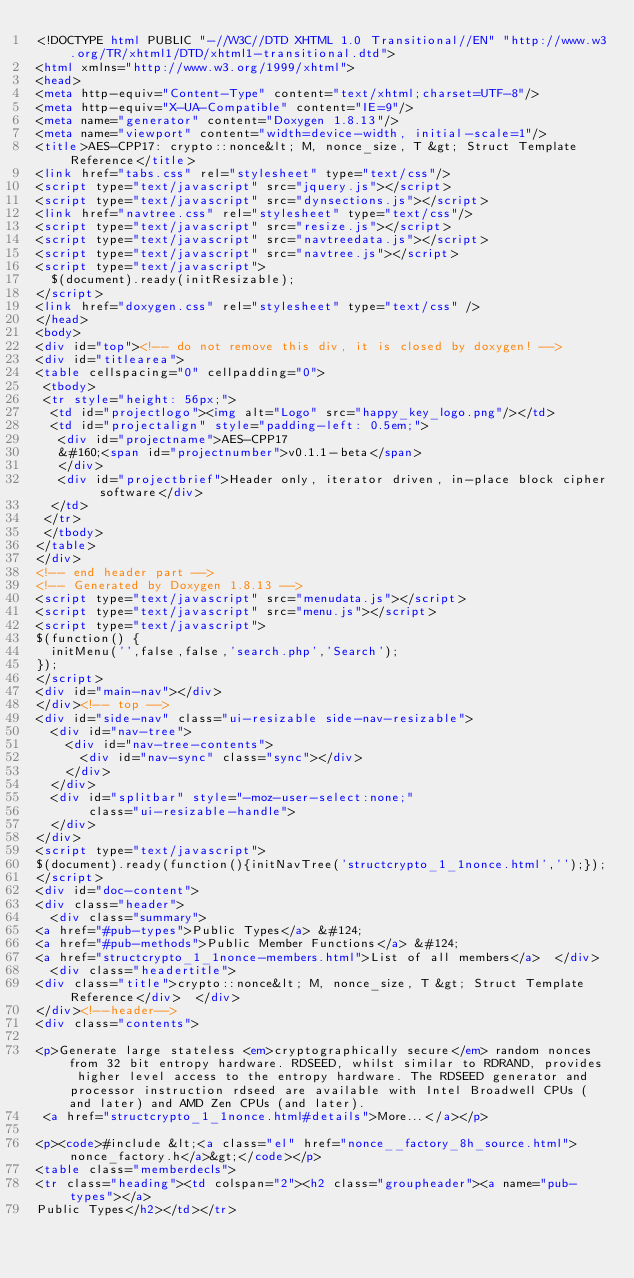Convert code to text. <code><loc_0><loc_0><loc_500><loc_500><_HTML_><!DOCTYPE html PUBLIC "-//W3C//DTD XHTML 1.0 Transitional//EN" "http://www.w3.org/TR/xhtml1/DTD/xhtml1-transitional.dtd">
<html xmlns="http://www.w3.org/1999/xhtml">
<head>
<meta http-equiv="Content-Type" content="text/xhtml;charset=UTF-8"/>
<meta http-equiv="X-UA-Compatible" content="IE=9"/>
<meta name="generator" content="Doxygen 1.8.13"/>
<meta name="viewport" content="width=device-width, initial-scale=1"/>
<title>AES-CPP17: crypto::nonce&lt; M, nonce_size, T &gt; Struct Template Reference</title>
<link href="tabs.css" rel="stylesheet" type="text/css"/>
<script type="text/javascript" src="jquery.js"></script>
<script type="text/javascript" src="dynsections.js"></script>
<link href="navtree.css" rel="stylesheet" type="text/css"/>
<script type="text/javascript" src="resize.js"></script>
<script type="text/javascript" src="navtreedata.js"></script>
<script type="text/javascript" src="navtree.js"></script>
<script type="text/javascript">
  $(document).ready(initResizable);
</script>
<link href="doxygen.css" rel="stylesheet" type="text/css" />
</head>
<body>
<div id="top"><!-- do not remove this div, it is closed by doxygen! -->
<div id="titlearea">
<table cellspacing="0" cellpadding="0">
 <tbody>
 <tr style="height: 56px;">
  <td id="projectlogo"><img alt="Logo" src="happy_key_logo.png"/></td>
  <td id="projectalign" style="padding-left: 0.5em;">
   <div id="projectname">AES-CPP17
   &#160;<span id="projectnumber">v0.1.1-beta</span>
   </div>
   <div id="projectbrief">Header only, iterator driven, in-place block cipher software</div>
  </td>
 </tr>
 </tbody>
</table>
</div>
<!-- end header part -->
<!-- Generated by Doxygen 1.8.13 -->
<script type="text/javascript" src="menudata.js"></script>
<script type="text/javascript" src="menu.js"></script>
<script type="text/javascript">
$(function() {
  initMenu('',false,false,'search.php','Search');
});
</script>
<div id="main-nav"></div>
</div><!-- top -->
<div id="side-nav" class="ui-resizable side-nav-resizable">
  <div id="nav-tree">
    <div id="nav-tree-contents">
      <div id="nav-sync" class="sync"></div>
    </div>
  </div>
  <div id="splitbar" style="-moz-user-select:none;" 
       class="ui-resizable-handle">
  </div>
</div>
<script type="text/javascript">
$(document).ready(function(){initNavTree('structcrypto_1_1nonce.html','');});
</script>
<div id="doc-content">
<div class="header">
  <div class="summary">
<a href="#pub-types">Public Types</a> &#124;
<a href="#pub-methods">Public Member Functions</a> &#124;
<a href="structcrypto_1_1nonce-members.html">List of all members</a>  </div>
  <div class="headertitle">
<div class="title">crypto::nonce&lt; M, nonce_size, T &gt; Struct Template Reference</div>  </div>
</div><!--header-->
<div class="contents">

<p>Generate large stateless <em>cryptographically secure</em> random nonces from 32 bit entropy hardware. RDSEED, whilst similar to RDRAND, provides higher level access to the entropy hardware. The RDSEED generator and processor instruction rdseed are available with Intel Broadwell CPUs (and later) and AMD Zen CPUs (and later).  
 <a href="structcrypto_1_1nonce.html#details">More...</a></p>

<p><code>#include &lt;<a class="el" href="nonce__factory_8h_source.html">nonce_factory.h</a>&gt;</code></p>
<table class="memberdecls">
<tr class="heading"><td colspan="2"><h2 class="groupheader"><a name="pub-types"></a>
Public Types</h2></td></tr></code> 